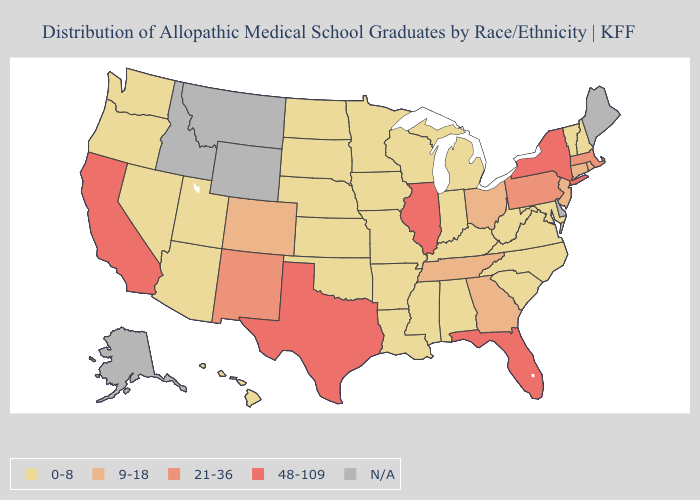Does Connecticut have the lowest value in the Northeast?
Concise answer only. No. What is the highest value in the South ?
Keep it brief. 48-109. What is the value of West Virginia?
Quick response, please. 0-8. Does South Carolina have the lowest value in the South?
Write a very short answer. Yes. Name the states that have a value in the range 48-109?
Be succinct. California, Florida, Illinois, New York, Texas. Among the states that border Massachusetts , does Vermont have the highest value?
Concise answer only. No. Name the states that have a value in the range 0-8?
Write a very short answer. Alabama, Arizona, Arkansas, Hawaii, Indiana, Iowa, Kansas, Kentucky, Louisiana, Maryland, Michigan, Minnesota, Mississippi, Missouri, Nebraska, Nevada, New Hampshire, North Carolina, North Dakota, Oklahoma, Oregon, South Carolina, South Dakota, Utah, Vermont, Virginia, Washington, West Virginia, Wisconsin. Among the states that border Louisiana , does Texas have the highest value?
Concise answer only. Yes. Among the states that border California , which have the highest value?
Write a very short answer. Arizona, Nevada, Oregon. What is the lowest value in the South?
Give a very brief answer. 0-8. Among the states that border Indiana , which have the lowest value?
Quick response, please. Kentucky, Michigan. What is the value of Ohio?
Be succinct. 9-18. Which states have the lowest value in the USA?
Quick response, please. Alabama, Arizona, Arkansas, Hawaii, Indiana, Iowa, Kansas, Kentucky, Louisiana, Maryland, Michigan, Minnesota, Mississippi, Missouri, Nebraska, Nevada, New Hampshire, North Carolina, North Dakota, Oklahoma, Oregon, South Carolina, South Dakota, Utah, Vermont, Virginia, Washington, West Virginia, Wisconsin. 